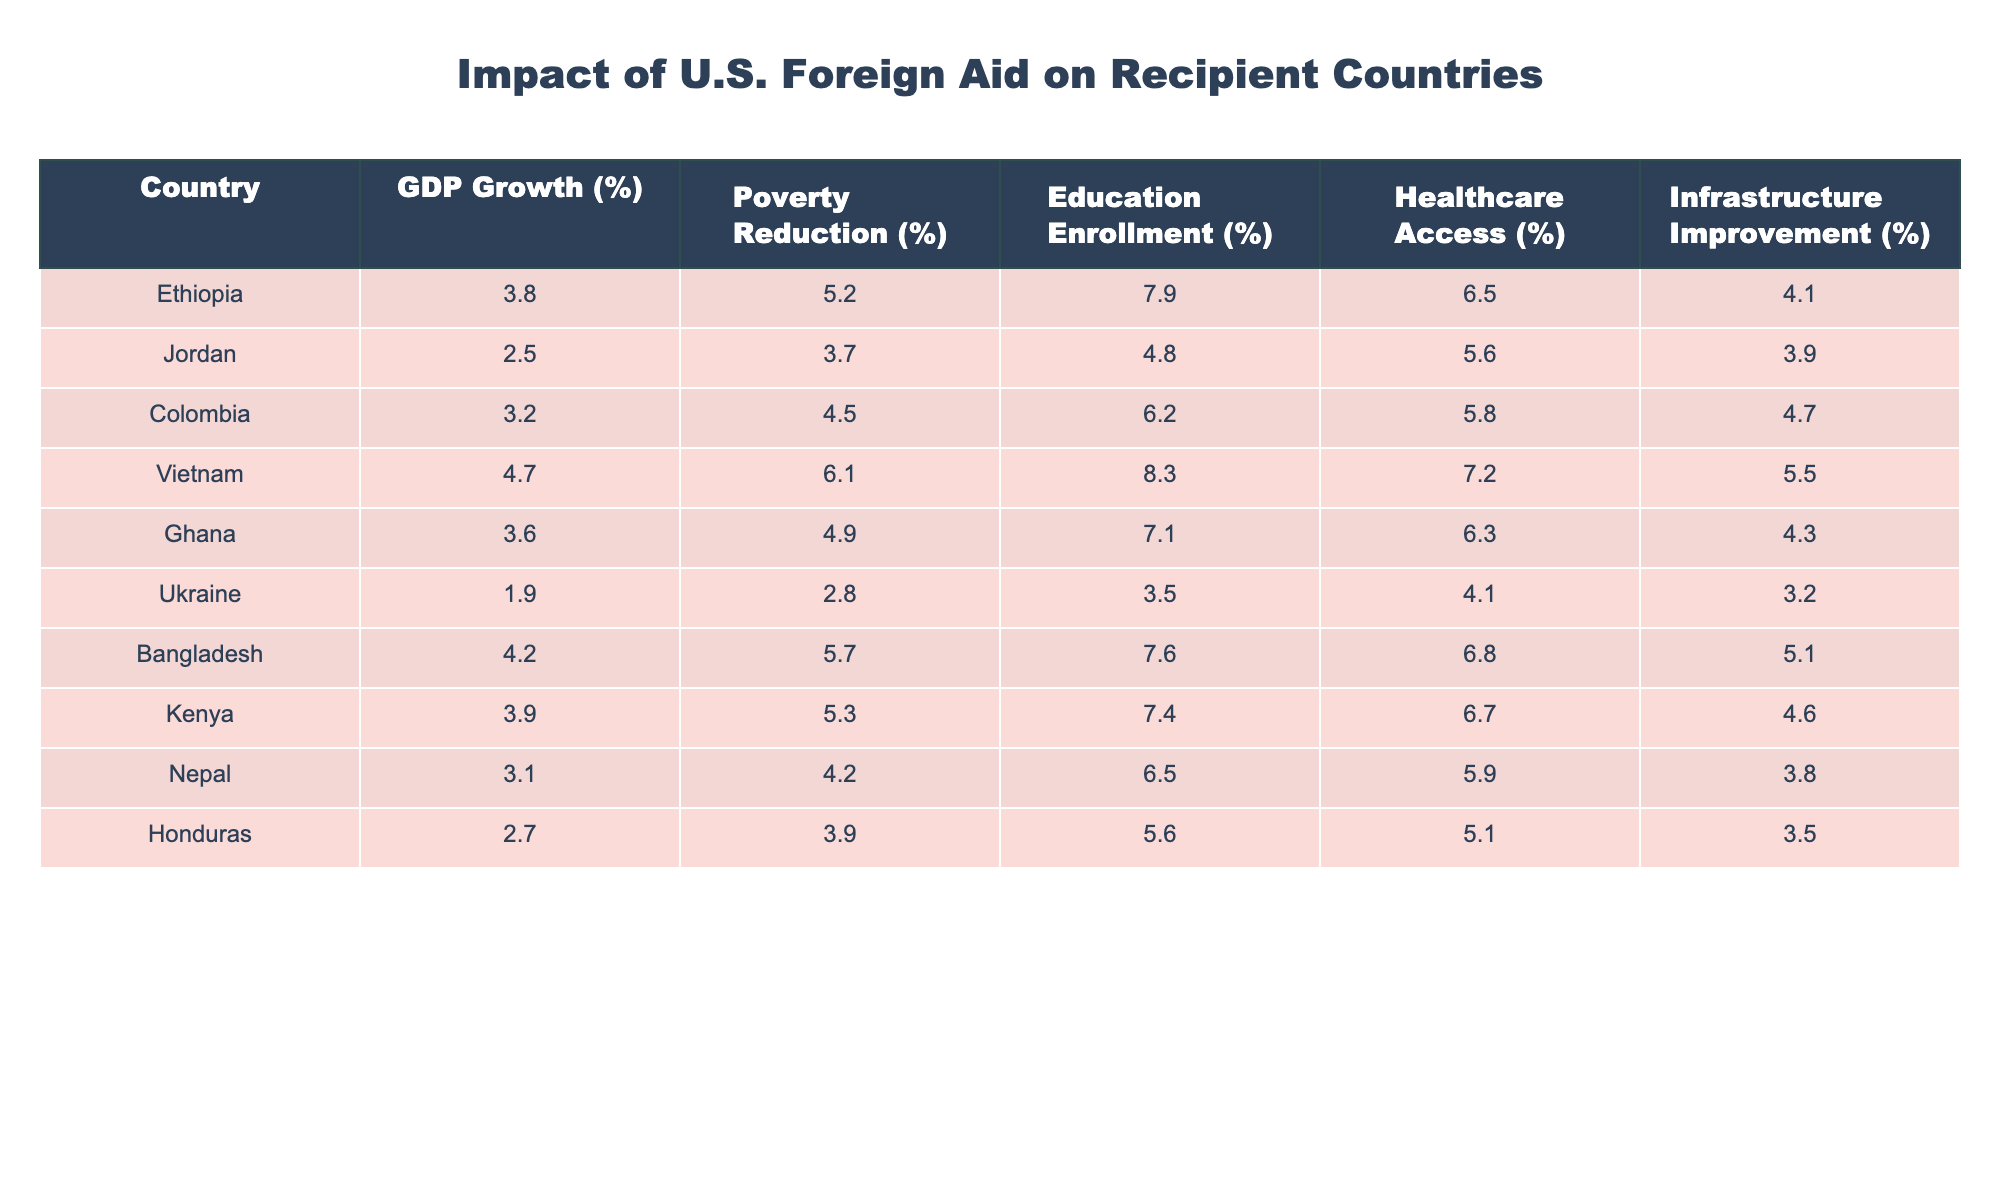What is the GDP growth percentage for Vietnam? Referring to the table, the GDP growth percentage for Vietnam is clearly listed in the appropriate row.
Answer: 4.7% Which country shows the highest rate of education enrollment? By examining the education enrollment percentages, I can identify that Vietnam has the highest rate at 8.3%.
Answer: Vietnam What is the difference in GDP growth between Ethiopia and Jordan? To find the difference, I subtract Jordan's GDP growth (2.5%) from Ethiopia's GDP growth (3.8%): 3.8% - 2.5% = 1.3%.
Answer: 1.3% True or False: Ukraine's poverty reduction percentage is greater than that of Colombia. By checking the poverty reduction values in the table, Ukraine's percentage is 2.8% while Colombia's is 4.5%. Therefore, the statement is false.
Answer: False What is the average healthcare access percentage across all countries listed? First, I sum all healthcare access percentages: 6.5 + 5.6 + 5.8 + 7.2 + 6.3 + 4.1 + 6.8 + 6.7 + 5.9 + 5.1 = 57.0%. Then, I divide by the number of countries (10): 57.0% / 10 = 5.7%.
Answer: 5.7% Which country has the lowest infrastructure improvement percentage? By examining the infrastructure improvement percentages for each country, I see that Ukraine has the lowest at 3.2%.
Answer: Ukraine If we consider the GDP growth of Honduras and Nepal, which one is greater and by how much? I compare the GDP growth of Honduras (2.7%) and Nepal (3.1%). Nepal's growth is greater by calculating the difference: 3.1% - 2.7% = 0.4%.
Answer: Nepal, 0.4% What is the combined poverty reduction percentage of Ethiopia and Bangladesh? I add the poverty reduction percentages for Ethiopia (5.2%) and Bangladesh (5.7%): 5.2% + 5.7% = 10.9%.
Answer: 10.9% Which country among those listed has the highest healthcare access percentage? I look through the healthcare access percentages in the table and find that Vietnam shows the highest at 7.2%.
Answer: Vietnam Is the education enrollment percentage for Ghana higher than that of Kenya? Comparing Ghana's education enrollment (7.1%) with Kenya's (7.4%), I determine that Ghana's percentage is lower than Kenya's, so the answer is no.
Answer: No What is the median GDP growth percentage from the provided data? First, I list the GDP growth percentages in ascending order: 1.9, 2.5, 2.7, 3.1, 3.2, 3.6, 3.8, 3.9, 4.2, 4.7. Since there are 10 values, the median will be the average of the 5th and 6th values: (3.2 + 3.6) / 2 = 3.4.
Answer: 3.4% 